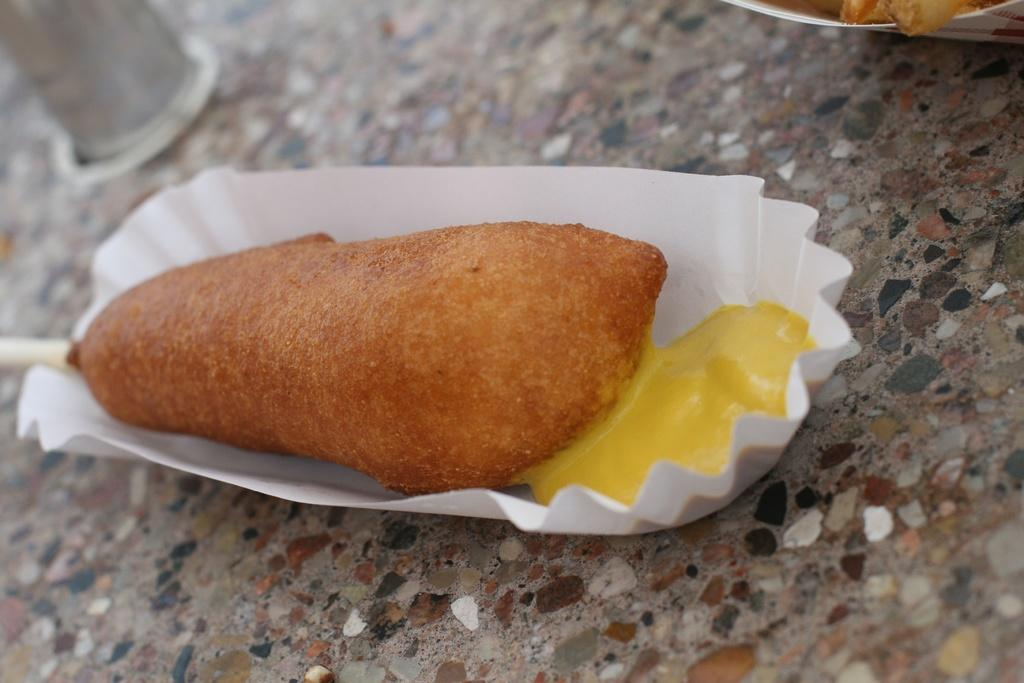What object is present in the image that is typically used for serving food? There is a paper plate in the image. What is on the paper plate in the image? The paper plate contains food. What historical event is depicted on the paper plate in the image? There is no historical event depicted on the paper plate in the image; it contains food. How does the paper plate contribute to pollution in the image? The paper plate does not contribute to pollution in the image; it is a single object in the design. 